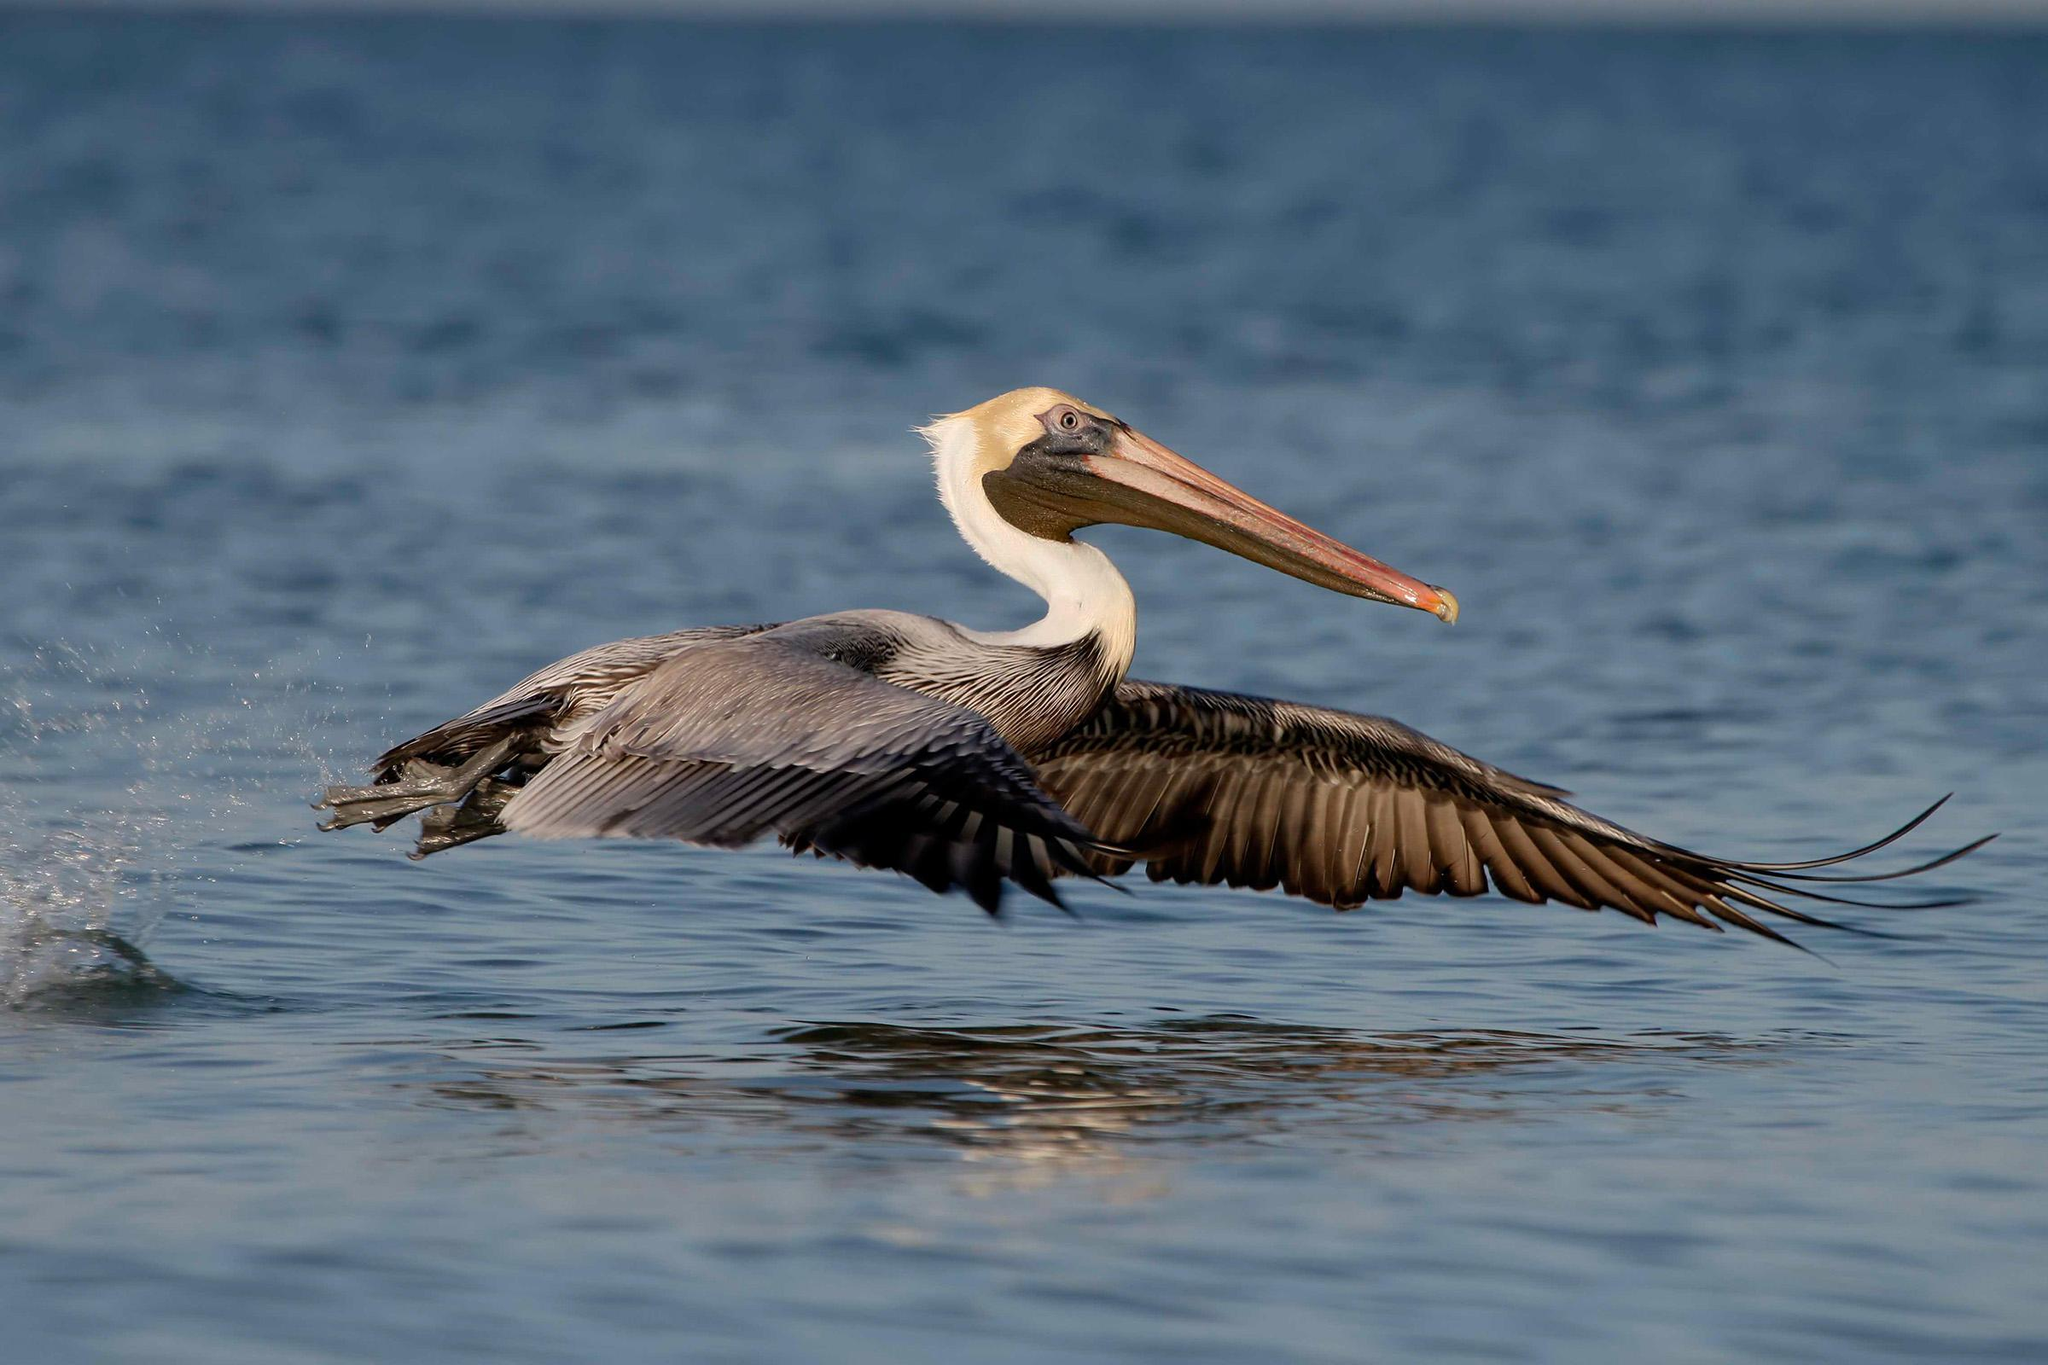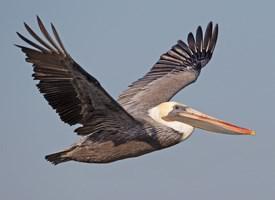The first image is the image on the left, the second image is the image on the right. Examine the images to the left and right. Is the description "One image shows three pelicans on the edge of a pier." accurate? Answer yes or no. No. The first image is the image on the left, the second image is the image on the right. Analyze the images presented: Is the assertion "There are no more than three pelicans" valid? Answer yes or no. Yes. 